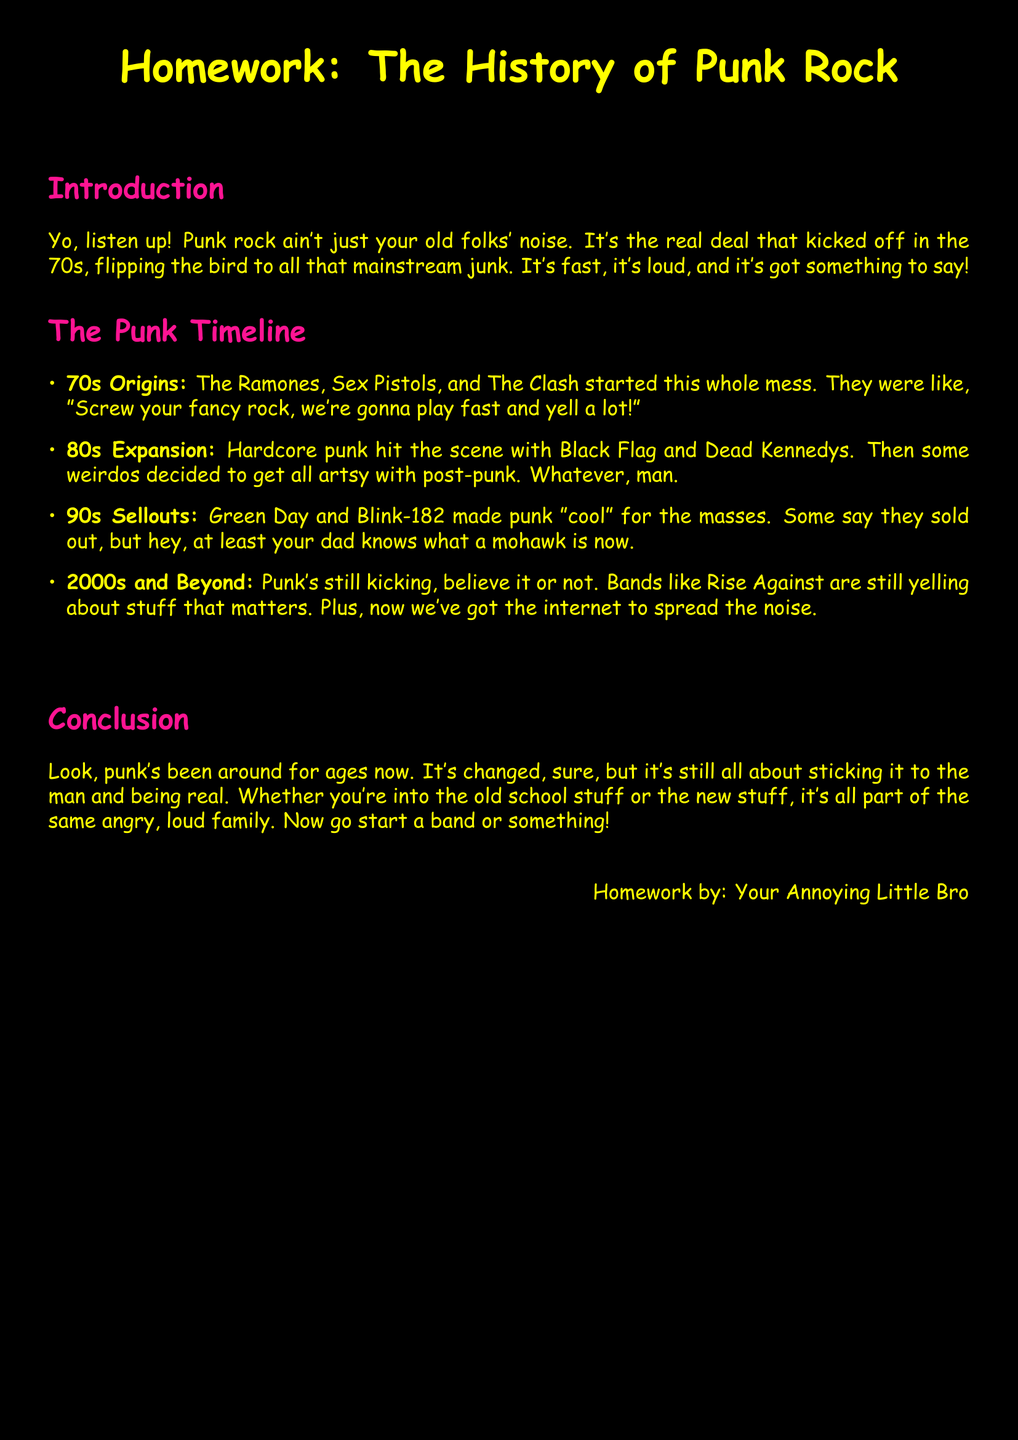What bands are mentioned in the 70s origins? The document lists the Ramones, Sex Pistols, and The Clash as key bands from the 70s origins of punk rock.
Answer: Ramones, Sex Pistols, The Clash Which decade saw the rise of hardcore punk? The document states that hardcore punk emerged in the 80s, particularly with bands like Black Flag and Dead Kennedys.
Answer: 80s What year range does the document focus on for punk rock history? The document outlines the history of punk rock starting from the 1970s and going to modern day, indicating a timeline that includes several decades.
Answer: 1970s to modern day What is noted about Green Day and Blink-182 in the document? The text mentions that Green Day and Blink-182 made punk "cool" for the masses in the 90s.
Answer: Made punk "cool" Which band is mentioned in the 2000s and Beyond section? The document refers to Rise Against as an active punk band in the 2000s and beyond.
Answer: Rise Against What is the overall theme discussed in the conclusion? The conclusion emphasizes that punk music is still about "sticking it to the man and being real," regardless of its evolution over the years.
Answer: Sticking it to the man How does the document describe the punk rock style? The text describes punk rock as fast, loud, and with something to say, reflecting its rebellious nature.
Answer: Fast, loud What is the segment style used for the document? The document is formatted as a homework assignment, structured with sections and a timeline format to present information clearly.
Answer: Homework 